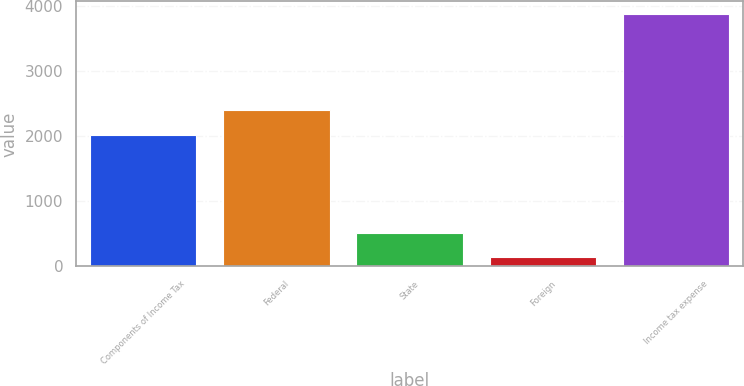Convert chart to OTSL. <chart><loc_0><loc_0><loc_500><loc_500><bar_chart><fcel>Components of Income Tax<fcel>Federal<fcel>State<fcel>Foreign<fcel>Income tax expense<nl><fcel>2014<fcel>2392<fcel>515.1<fcel>142<fcel>3873<nl></chart> 